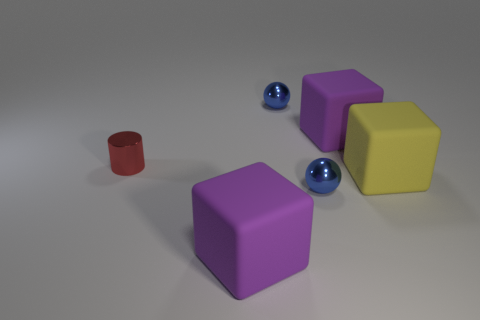How many other yellow matte blocks have the same size as the yellow matte cube?
Offer a terse response. 0. Are there more matte cubes behind the big yellow object than blue metal things in front of the red metal cylinder?
Your response must be concise. No. What color is the small cylinder on the left side of the big matte thing in front of the yellow thing?
Provide a short and direct response. Red. Are there any other big matte things that have the same shape as the large yellow matte thing?
Ensure brevity in your answer.  Yes. Is the size of the blue metallic thing that is behind the tiny red metallic cylinder the same as the shiny thing in front of the metal cylinder?
Your answer should be compact. Yes. How many big matte cubes are to the left of the yellow cube and in front of the tiny cylinder?
Offer a very short reply. 1. What number of things are blue spheres or metal objects that are in front of the big yellow rubber thing?
Ensure brevity in your answer.  2. What color is the metal sphere in front of the tiny cylinder?
Ensure brevity in your answer.  Blue. How many things are tiny shiny objects that are behind the tiny red metal cylinder or purple cubes?
Your answer should be compact. 3. Are there more large purple cubes to the right of the red object than rubber balls?
Your response must be concise. Yes. 